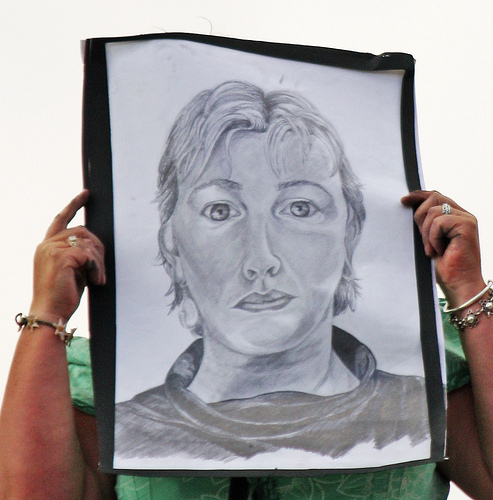<image>
Is there a portrait behind the person? No. The portrait is not behind the person. From this viewpoint, the portrait appears to be positioned elsewhere in the scene. Is the left arm next to the right arm? Yes. The left arm is positioned adjacent to the right arm, located nearby in the same general area. 